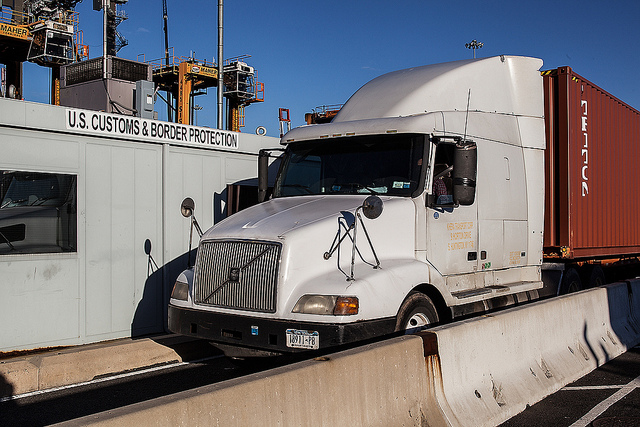What happens if a truck fails the inspection at the border? If a truck fails the inspection at the border, several actions might follow depending on the nature of the issue. It could be sent to a secondary inspection area for a more detailed check. If contraband or discrepancies are found, law enforcement may become involved, and the driver could face fines or more severe penalties. The cargo might be confiscated, and the truck held until the investigation is concluded and all legal issues are resolved. 